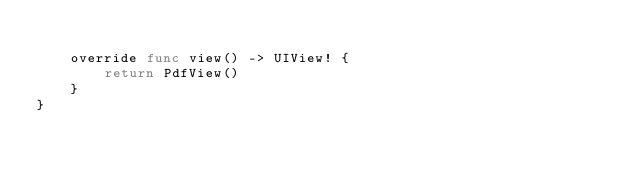<code> <loc_0><loc_0><loc_500><loc_500><_Swift_>
    override func view() -> UIView! {
        return PdfView()
    }
}
</code> 